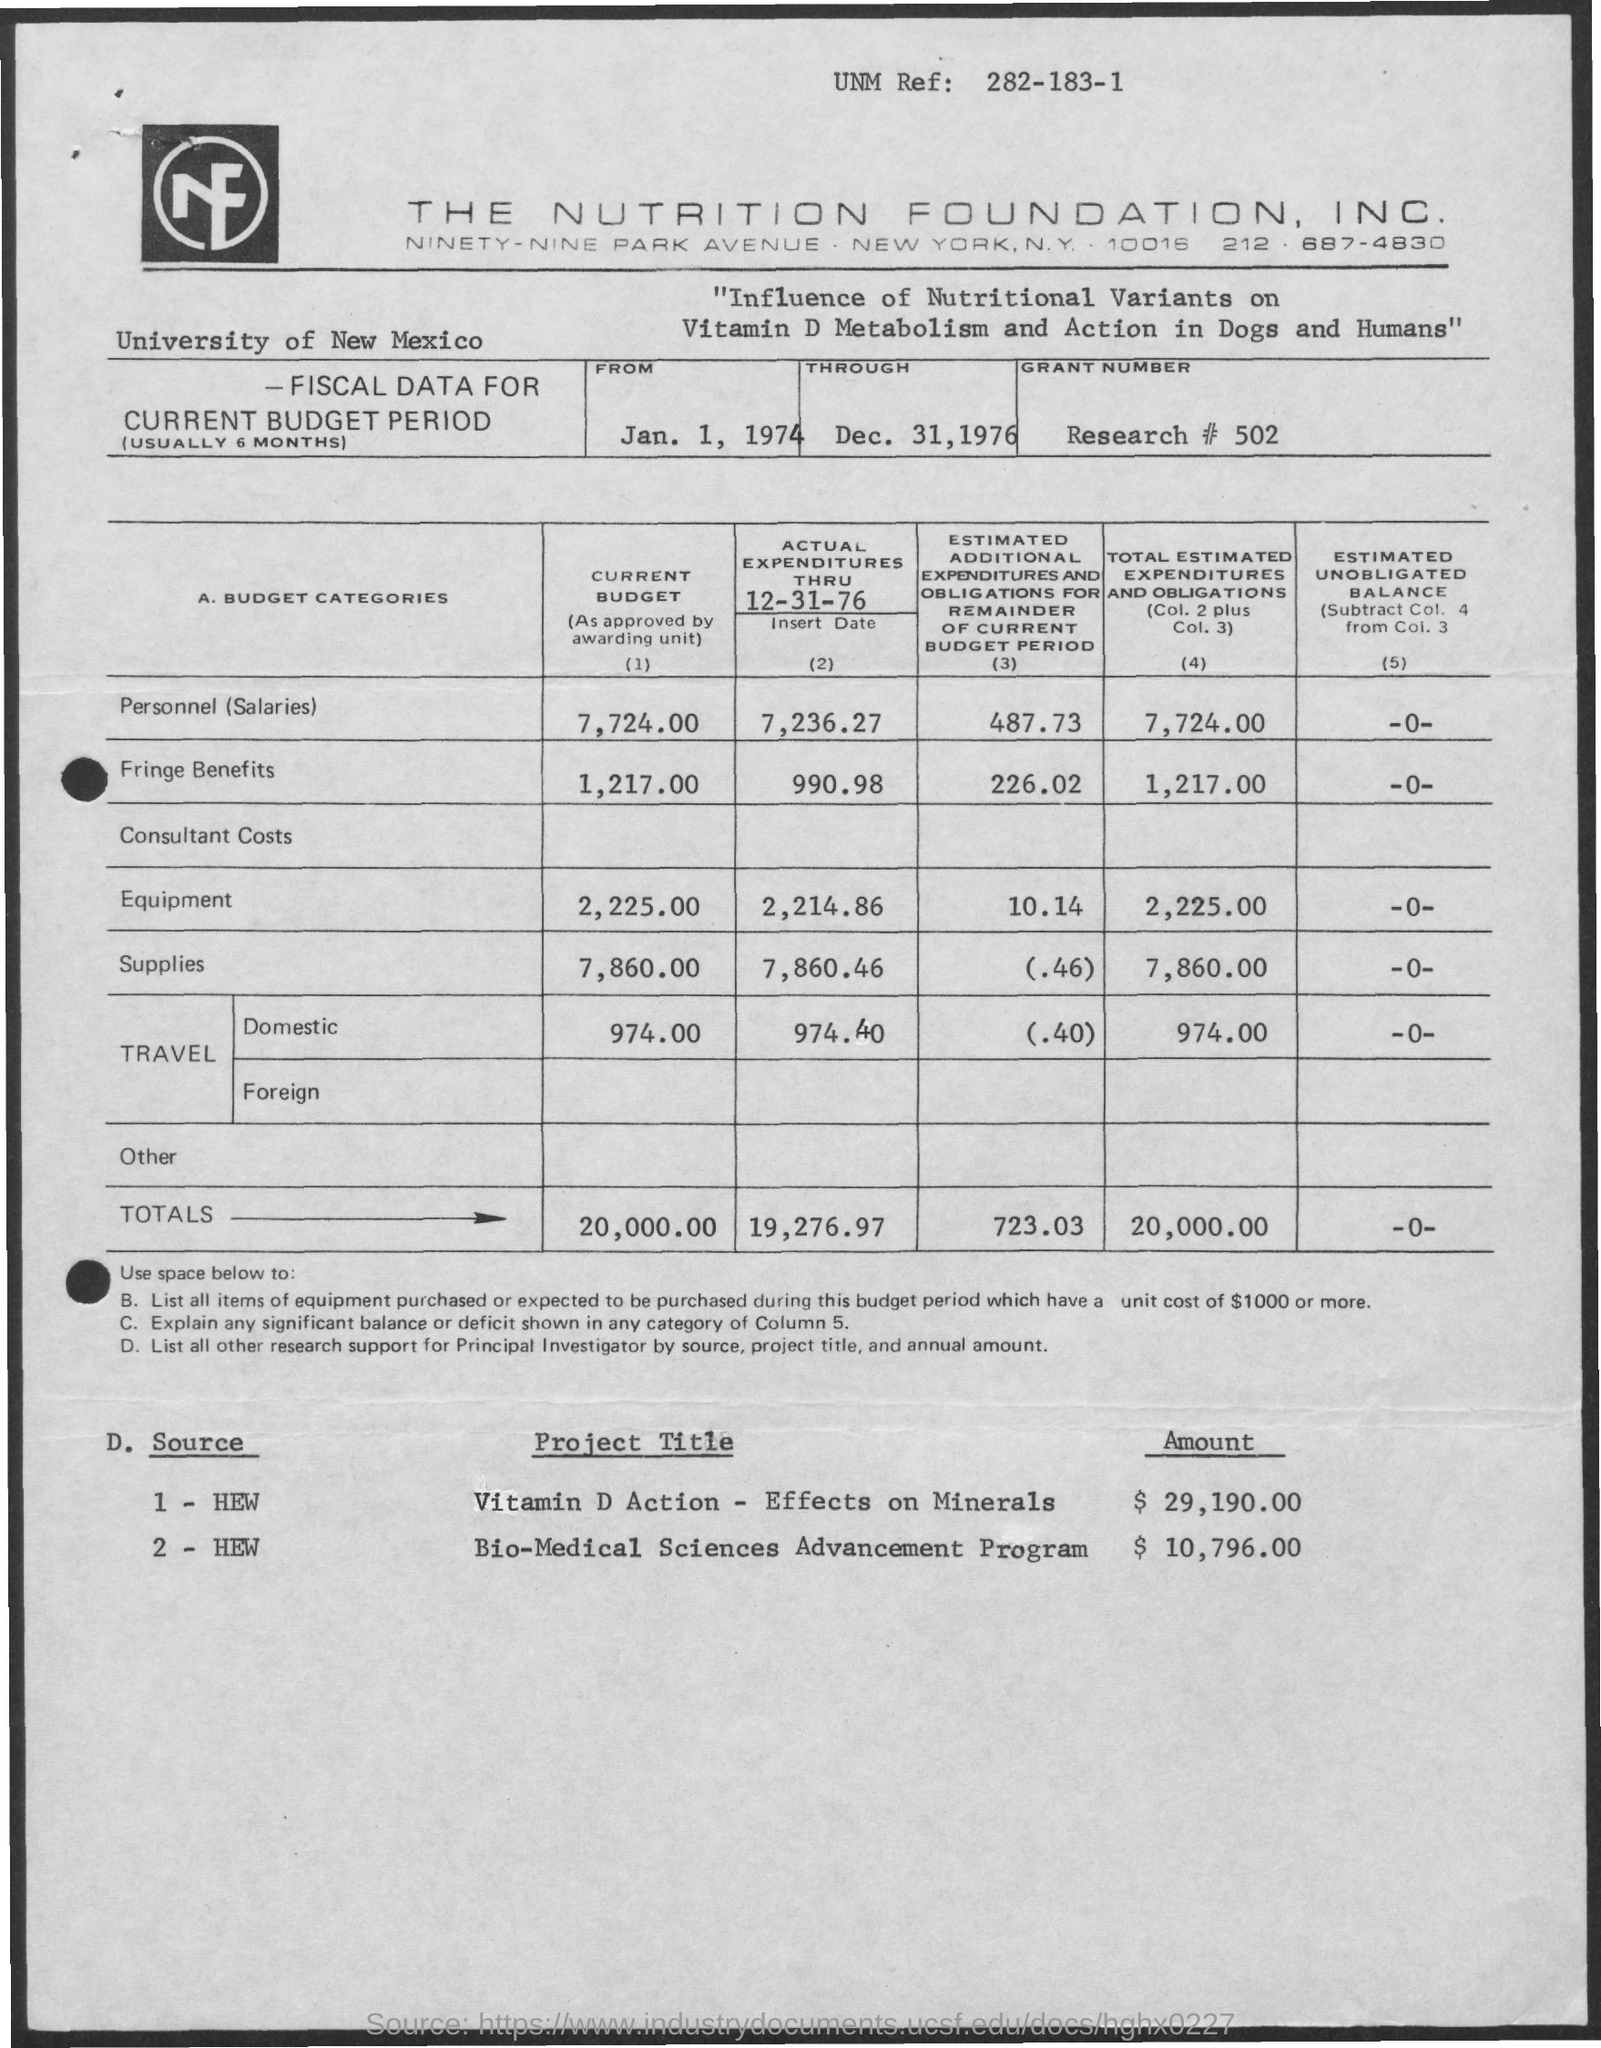What is the name of the university mentioned in the given page ?
Provide a short and direct response. University of new mexico. What is the amount of personnel (salaries) in the current budget ?
Offer a terse response. 7,724.00. What is the amount of fringe benefits in the current budget ?
Keep it short and to the point. 1,217.00. What is the amount of actual expenditures thru 12-31-76 for equipment ?
Make the answer very short. 2,214.86. What is the total amount shown in the current budget ?
Give a very brief answer. 20,000.00. What is the total amount for actual expenditures thru 12-31-76 ?
Ensure brevity in your answer.  19,276.97. What is the total amount for estimated additional expenditures and obligations for remainder of current budget period ?
Give a very brief answer. 723.03. What is the total amount of total estimated expenditures and obligations ?
Your answer should be very brief. 20,000.00. What is the amount for vitamin d action-effects on minerals ?
Give a very brief answer. $ 29,190.00. What is the amount given for bio medical sciences advancement program ?
Your answer should be very brief. $ 10,796.00. 